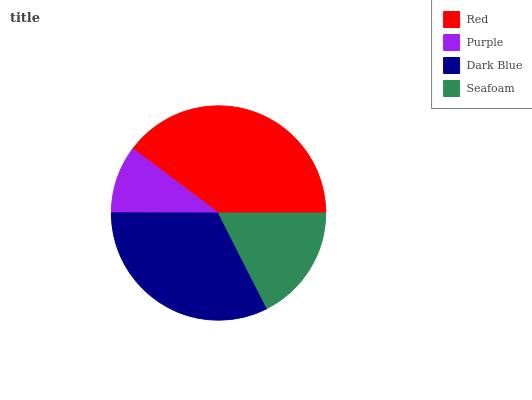Is Purple the minimum?
Answer yes or no. Yes. Is Red the maximum?
Answer yes or no. Yes. Is Dark Blue the minimum?
Answer yes or no. No. Is Dark Blue the maximum?
Answer yes or no. No. Is Dark Blue greater than Purple?
Answer yes or no. Yes. Is Purple less than Dark Blue?
Answer yes or no. Yes. Is Purple greater than Dark Blue?
Answer yes or no. No. Is Dark Blue less than Purple?
Answer yes or no. No. Is Dark Blue the high median?
Answer yes or no. Yes. Is Seafoam the low median?
Answer yes or no. Yes. Is Seafoam the high median?
Answer yes or no. No. Is Red the low median?
Answer yes or no. No. 